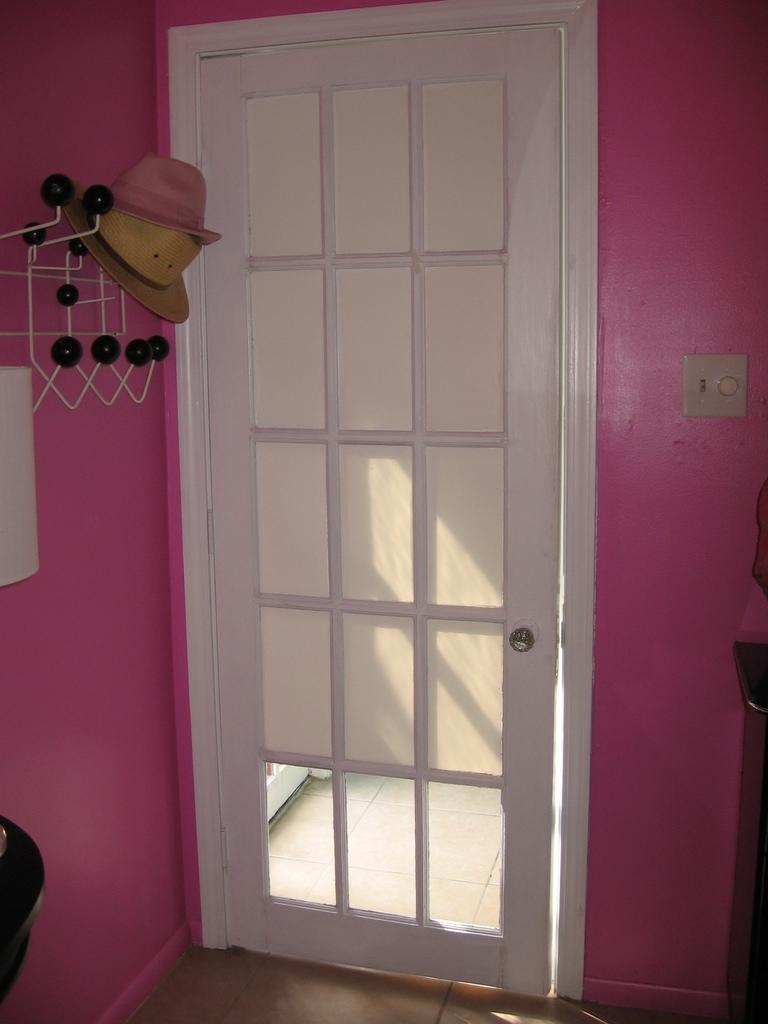What type of object can be seen in the image that provides access to another space? There is a door in the image that provides access to another space. What is the color of the door in the image? The door is white in color. What items are hanging on a hanger in the image? There are hats on a hanger in the image. What color is the wall in the image? The wall is pink in color. Reasoning: Let' Let's think step by step in order to produce the conversation. We start by identifying the main object in the image, which is the door. Then, we describe the door's color and mention the presence of hats on a hanger. Finally, we note the color of the wall in the image. Each question is designed to elicit a specific detail about the image that is known from the provided facts. Absurd Question/Answer: How many beds can be seen in the image? There are no beds present in the image. What type of hair is visible on the door in the image? There is no hair visible on the door in the image, as it is an inanimate object. What type of hair is visible on the door in the image? There is no hair visible on the door in the image, as it is an inanimate object. 